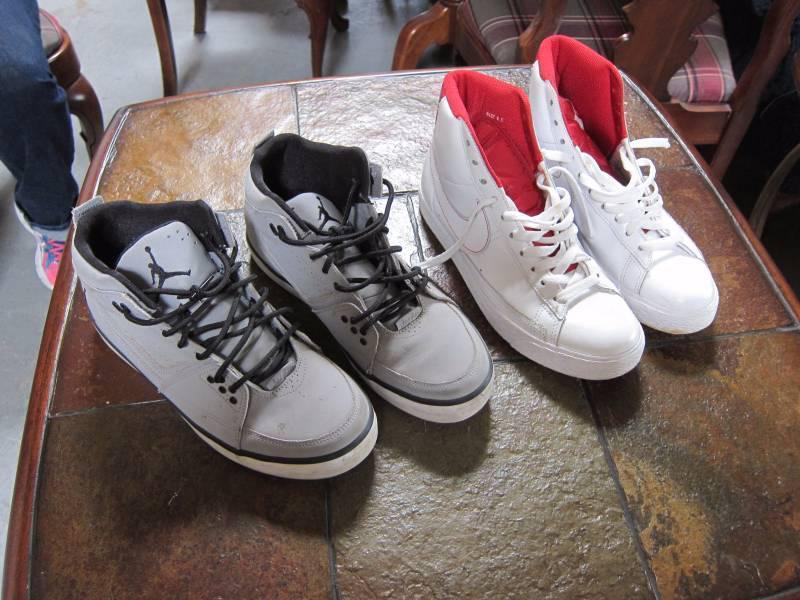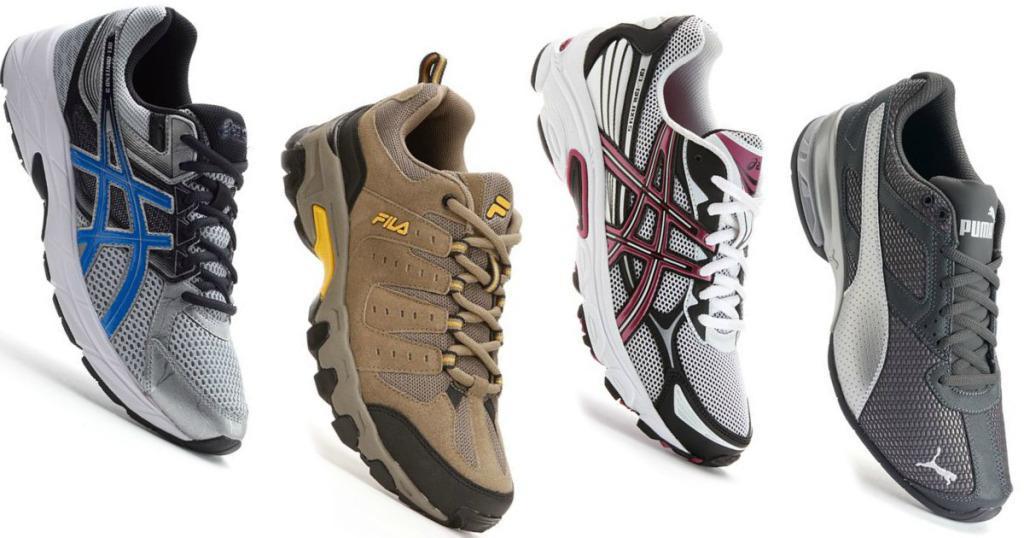The first image is the image on the left, the second image is the image on the right. Assess this claim about the two images: "Someone is wearing the shoes in one of the images.". Correct or not? Answer yes or no. No. The first image is the image on the left, the second image is the image on the right. Considering the images on both sides, is "In one of the images, a pair of shoes with a white sole are modelled by a human." valid? Answer yes or no. No. 